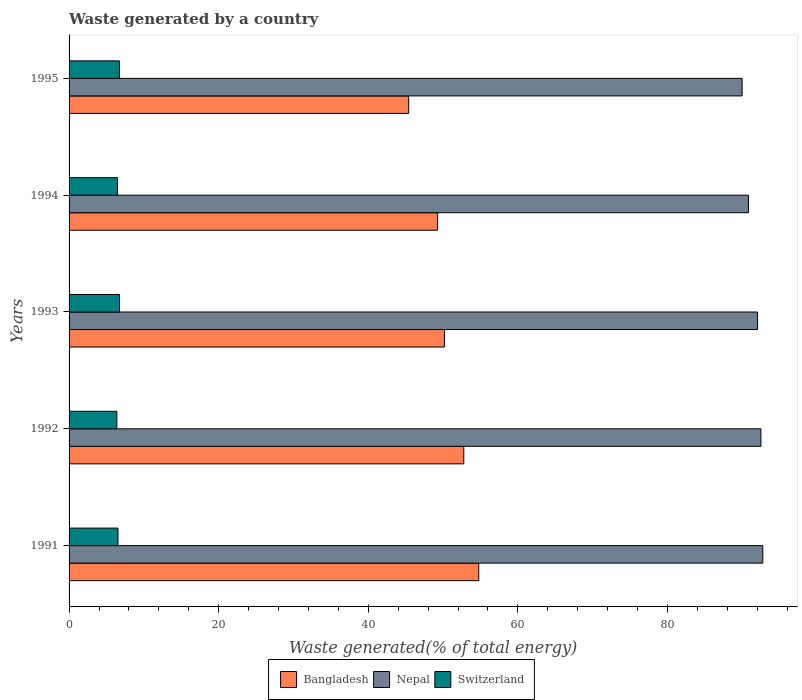Are the number of bars per tick equal to the number of legend labels?
Give a very brief answer. Yes. How many bars are there on the 3rd tick from the top?
Make the answer very short. 3. What is the label of the 2nd group of bars from the top?
Ensure brevity in your answer.  1994. What is the total waste generated in Nepal in 1995?
Offer a very short reply. 89.97. Across all years, what is the maximum total waste generated in Bangladesh?
Provide a succinct answer. 54.76. Across all years, what is the minimum total waste generated in Nepal?
Offer a terse response. 89.97. What is the total total waste generated in Bangladesh in the graph?
Make the answer very short. 252.37. What is the difference between the total waste generated in Switzerland in 1993 and that in 1994?
Offer a very short reply. 0.27. What is the difference between the total waste generated in Nepal in 1994 and the total waste generated in Switzerland in 1993?
Provide a succinct answer. 84.07. What is the average total waste generated in Switzerland per year?
Give a very brief answer. 6.58. In the year 1993, what is the difference between the total waste generated in Switzerland and total waste generated in Nepal?
Your answer should be very brief. -85.29. What is the ratio of the total waste generated in Nepal in 1993 to that in 1995?
Your answer should be very brief. 1.02. What is the difference between the highest and the second highest total waste generated in Bangladesh?
Provide a succinct answer. 2. What is the difference between the highest and the lowest total waste generated in Bangladesh?
Ensure brevity in your answer.  9.37. What does the 1st bar from the top in 1995 represents?
Provide a succinct answer. Switzerland. Are all the bars in the graph horizontal?
Give a very brief answer. Yes. How many years are there in the graph?
Give a very brief answer. 5. Are the values on the major ticks of X-axis written in scientific E-notation?
Offer a terse response. No. Does the graph contain any zero values?
Give a very brief answer. No. How are the legend labels stacked?
Offer a terse response. Horizontal. What is the title of the graph?
Offer a very short reply. Waste generated by a country. What is the label or title of the X-axis?
Your answer should be compact. Waste generated(% of total energy). What is the Waste generated(% of total energy) in Bangladesh in 1991?
Offer a very short reply. 54.76. What is the Waste generated(% of total energy) in Nepal in 1991?
Provide a succinct answer. 92.74. What is the Waste generated(% of total energy) in Switzerland in 1991?
Keep it short and to the point. 6.54. What is the Waste generated(% of total energy) in Bangladesh in 1992?
Your response must be concise. 52.77. What is the Waste generated(% of total energy) of Nepal in 1992?
Make the answer very short. 92.48. What is the Waste generated(% of total energy) in Switzerland in 1992?
Your answer should be very brief. 6.39. What is the Waste generated(% of total energy) in Bangladesh in 1993?
Provide a succinct answer. 50.18. What is the Waste generated(% of total energy) of Nepal in 1993?
Offer a very short reply. 92.04. What is the Waste generated(% of total energy) in Switzerland in 1993?
Your answer should be very brief. 6.75. What is the Waste generated(% of total energy) of Bangladesh in 1994?
Your answer should be very brief. 49.26. What is the Waste generated(% of total energy) of Nepal in 1994?
Ensure brevity in your answer.  90.82. What is the Waste generated(% of total energy) of Switzerland in 1994?
Keep it short and to the point. 6.47. What is the Waste generated(% of total energy) in Bangladesh in 1995?
Provide a short and direct response. 45.4. What is the Waste generated(% of total energy) in Nepal in 1995?
Offer a very short reply. 89.97. What is the Waste generated(% of total energy) of Switzerland in 1995?
Give a very brief answer. 6.73. Across all years, what is the maximum Waste generated(% of total energy) in Bangladesh?
Offer a very short reply. 54.76. Across all years, what is the maximum Waste generated(% of total energy) of Nepal?
Your answer should be compact. 92.74. Across all years, what is the maximum Waste generated(% of total energy) in Switzerland?
Provide a succinct answer. 6.75. Across all years, what is the minimum Waste generated(% of total energy) of Bangladesh?
Ensure brevity in your answer.  45.4. Across all years, what is the minimum Waste generated(% of total energy) in Nepal?
Offer a very short reply. 89.97. Across all years, what is the minimum Waste generated(% of total energy) of Switzerland?
Your answer should be very brief. 6.39. What is the total Waste generated(% of total energy) in Bangladesh in the graph?
Give a very brief answer. 252.37. What is the total Waste generated(% of total energy) of Nepal in the graph?
Offer a terse response. 458.05. What is the total Waste generated(% of total energy) of Switzerland in the graph?
Your answer should be compact. 32.89. What is the difference between the Waste generated(% of total energy) of Bangladesh in 1991 and that in 1992?
Ensure brevity in your answer.  2. What is the difference between the Waste generated(% of total energy) in Nepal in 1991 and that in 1992?
Ensure brevity in your answer.  0.25. What is the difference between the Waste generated(% of total energy) in Switzerland in 1991 and that in 1992?
Offer a terse response. 0.15. What is the difference between the Waste generated(% of total energy) in Bangladesh in 1991 and that in 1993?
Offer a terse response. 4.59. What is the difference between the Waste generated(% of total energy) in Nepal in 1991 and that in 1993?
Give a very brief answer. 0.7. What is the difference between the Waste generated(% of total energy) in Switzerland in 1991 and that in 1993?
Ensure brevity in your answer.  -0.21. What is the difference between the Waste generated(% of total energy) in Bangladesh in 1991 and that in 1994?
Ensure brevity in your answer.  5.5. What is the difference between the Waste generated(% of total energy) of Nepal in 1991 and that in 1994?
Keep it short and to the point. 1.92. What is the difference between the Waste generated(% of total energy) of Switzerland in 1991 and that in 1994?
Your answer should be compact. 0.07. What is the difference between the Waste generated(% of total energy) in Bangladesh in 1991 and that in 1995?
Your answer should be very brief. 9.37. What is the difference between the Waste generated(% of total energy) in Nepal in 1991 and that in 1995?
Your answer should be compact. 2.76. What is the difference between the Waste generated(% of total energy) in Switzerland in 1991 and that in 1995?
Your answer should be compact. -0.19. What is the difference between the Waste generated(% of total energy) of Bangladesh in 1992 and that in 1993?
Provide a short and direct response. 2.59. What is the difference between the Waste generated(% of total energy) of Nepal in 1992 and that in 1993?
Ensure brevity in your answer.  0.45. What is the difference between the Waste generated(% of total energy) of Switzerland in 1992 and that in 1993?
Offer a very short reply. -0.36. What is the difference between the Waste generated(% of total energy) of Bangladesh in 1992 and that in 1994?
Your answer should be very brief. 3.5. What is the difference between the Waste generated(% of total energy) of Nepal in 1992 and that in 1994?
Your response must be concise. 1.66. What is the difference between the Waste generated(% of total energy) of Switzerland in 1992 and that in 1994?
Your answer should be very brief. -0.09. What is the difference between the Waste generated(% of total energy) of Bangladesh in 1992 and that in 1995?
Provide a short and direct response. 7.37. What is the difference between the Waste generated(% of total energy) in Nepal in 1992 and that in 1995?
Your response must be concise. 2.51. What is the difference between the Waste generated(% of total energy) in Switzerland in 1992 and that in 1995?
Make the answer very short. -0.35. What is the difference between the Waste generated(% of total energy) in Bangladesh in 1993 and that in 1994?
Your answer should be compact. 0.92. What is the difference between the Waste generated(% of total energy) in Nepal in 1993 and that in 1994?
Your response must be concise. 1.22. What is the difference between the Waste generated(% of total energy) of Switzerland in 1993 and that in 1994?
Offer a very short reply. 0.27. What is the difference between the Waste generated(% of total energy) of Bangladesh in 1993 and that in 1995?
Your response must be concise. 4.78. What is the difference between the Waste generated(% of total energy) of Nepal in 1993 and that in 1995?
Give a very brief answer. 2.06. What is the difference between the Waste generated(% of total energy) of Switzerland in 1993 and that in 1995?
Give a very brief answer. 0.01. What is the difference between the Waste generated(% of total energy) of Bangladesh in 1994 and that in 1995?
Ensure brevity in your answer.  3.86. What is the difference between the Waste generated(% of total energy) in Nepal in 1994 and that in 1995?
Offer a very short reply. 0.84. What is the difference between the Waste generated(% of total energy) in Switzerland in 1994 and that in 1995?
Offer a terse response. -0.26. What is the difference between the Waste generated(% of total energy) in Bangladesh in 1991 and the Waste generated(% of total energy) in Nepal in 1992?
Make the answer very short. -37.72. What is the difference between the Waste generated(% of total energy) of Bangladesh in 1991 and the Waste generated(% of total energy) of Switzerland in 1992?
Ensure brevity in your answer.  48.38. What is the difference between the Waste generated(% of total energy) in Nepal in 1991 and the Waste generated(% of total energy) in Switzerland in 1992?
Keep it short and to the point. 86.35. What is the difference between the Waste generated(% of total energy) of Bangladesh in 1991 and the Waste generated(% of total energy) of Nepal in 1993?
Give a very brief answer. -37.27. What is the difference between the Waste generated(% of total energy) in Bangladesh in 1991 and the Waste generated(% of total energy) in Switzerland in 1993?
Make the answer very short. 48.02. What is the difference between the Waste generated(% of total energy) of Nepal in 1991 and the Waste generated(% of total energy) of Switzerland in 1993?
Provide a short and direct response. 85.99. What is the difference between the Waste generated(% of total energy) of Bangladesh in 1991 and the Waste generated(% of total energy) of Nepal in 1994?
Make the answer very short. -36.05. What is the difference between the Waste generated(% of total energy) in Bangladesh in 1991 and the Waste generated(% of total energy) in Switzerland in 1994?
Offer a terse response. 48.29. What is the difference between the Waste generated(% of total energy) in Nepal in 1991 and the Waste generated(% of total energy) in Switzerland in 1994?
Provide a succinct answer. 86.26. What is the difference between the Waste generated(% of total energy) in Bangladesh in 1991 and the Waste generated(% of total energy) in Nepal in 1995?
Your response must be concise. -35.21. What is the difference between the Waste generated(% of total energy) of Bangladesh in 1991 and the Waste generated(% of total energy) of Switzerland in 1995?
Ensure brevity in your answer.  48.03. What is the difference between the Waste generated(% of total energy) of Nepal in 1991 and the Waste generated(% of total energy) of Switzerland in 1995?
Give a very brief answer. 86. What is the difference between the Waste generated(% of total energy) of Bangladesh in 1992 and the Waste generated(% of total energy) of Nepal in 1993?
Your response must be concise. -39.27. What is the difference between the Waste generated(% of total energy) of Bangladesh in 1992 and the Waste generated(% of total energy) of Switzerland in 1993?
Your response must be concise. 46.02. What is the difference between the Waste generated(% of total energy) in Nepal in 1992 and the Waste generated(% of total energy) in Switzerland in 1993?
Offer a terse response. 85.74. What is the difference between the Waste generated(% of total energy) of Bangladesh in 1992 and the Waste generated(% of total energy) of Nepal in 1994?
Offer a very short reply. -38.05. What is the difference between the Waste generated(% of total energy) of Bangladesh in 1992 and the Waste generated(% of total energy) of Switzerland in 1994?
Give a very brief answer. 46.29. What is the difference between the Waste generated(% of total energy) in Nepal in 1992 and the Waste generated(% of total energy) in Switzerland in 1994?
Ensure brevity in your answer.  86.01. What is the difference between the Waste generated(% of total energy) in Bangladesh in 1992 and the Waste generated(% of total energy) in Nepal in 1995?
Your answer should be compact. -37.21. What is the difference between the Waste generated(% of total energy) in Bangladesh in 1992 and the Waste generated(% of total energy) in Switzerland in 1995?
Give a very brief answer. 46.03. What is the difference between the Waste generated(% of total energy) of Nepal in 1992 and the Waste generated(% of total energy) of Switzerland in 1995?
Your answer should be very brief. 85.75. What is the difference between the Waste generated(% of total energy) in Bangladesh in 1993 and the Waste generated(% of total energy) in Nepal in 1994?
Make the answer very short. -40.64. What is the difference between the Waste generated(% of total energy) in Bangladesh in 1993 and the Waste generated(% of total energy) in Switzerland in 1994?
Offer a very short reply. 43.71. What is the difference between the Waste generated(% of total energy) of Nepal in 1993 and the Waste generated(% of total energy) of Switzerland in 1994?
Give a very brief answer. 85.56. What is the difference between the Waste generated(% of total energy) in Bangladesh in 1993 and the Waste generated(% of total energy) in Nepal in 1995?
Offer a very short reply. -39.79. What is the difference between the Waste generated(% of total energy) in Bangladesh in 1993 and the Waste generated(% of total energy) in Switzerland in 1995?
Your response must be concise. 43.44. What is the difference between the Waste generated(% of total energy) in Nepal in 1993 and the Waste generated(% of total energy) in Switzerland in 1995?
Keep it short and to the point. 85.3. What is the difference between the Waste generated(% of total energy) in Bangladesh in 1994 and the Waste generated(% of total energy) in Nepal in 1995?
Make the answer very short. -40.71. What is the difference between the Waste generated(% of total energy) in Bangladesh in 1994 and the Waste generated(% of total energy) in Switzerland in 1995?
Make the answer very short. 42.53. What is the difference between the Waste generated(% of total energy) of Nepal in 1994 and the Waste generated(% of total energy) of Switzerland in 1995?
Keep it short and to the point. 84.08. What is the average Waste generated(% of total energy) in Bangladesh per year?
Keep it short and to the point. 50.47. What is the average Waste generated(% of total energy) in Nepal per year?
Provide a short and direct response. 91.61. What is the average Waste generated(% of total energy) of Switzerland per year?
Offer a very short reply. 6.58. In the year 1991, what is the difference between the Waste generated(% of total energy) of Bangladesh and Waste generated(% of total energy) of Nepal?
Provide a short and direct response. -37.97. In the year 1991, what is the difference between the Waste generated(% of total energy) of Bangladesh and Waste generated(% of total energy) of Switzerland?
Make the answer very short. 48.22. In the year 1991, what is the difference between the Waste generated(% of total energy) in Nepal and Waste generated(% of total energy) in Switzerland?
Make the answer very short. 86.2. In the year 1992, what is the difference between the Waste generated(% of total energy) of Bangladesh and Waste generated(% of total energy) of Nepal?
Your answer should be very brief. -39.72. In the year 1992, what is the difference between the Waste generated(% of total energy) in Bangladesh and Waste generated(% of total energy) in Switzerland?
Keep it short and to the point. 46.38. In the year 1992, what is the difference between the Waste generated(% of total energy) in Nepal and Waste generated(% of total energy) in Switzerland?
Your answer should be very brief. 86.1. In the year 1993, what is the difference between the Waste generated(% of total energy) of Bangladesh and Waste generated(% of total energy) of Nepal?
Offer a terse response. -41.86. In the year 1993, what is the difference between the Waste generated(% of total energy) in Bangladesh and Waste generated(% of total energy) in Switzerland?
Provide a short and direct response. 43.43. In the year 1993, what is the difference between the Waste generated(% of total energy) in Nepal and Waste generated(% of total energy) in Switzerland?
Your answer should be very brief. 85.29. In the year 1994, what is the difference between the Waste generated(% of total energy) in Bangladesh and Waste generated(% of total energy) in Nepal?
Provide a short and direct response. -41.56. In the year 1994, what is the difference between the Waste generated(% of total energy) of Bangladesh and Waste generated(% of total energy) of Switzerland?
Provide a succinct answer. 42.79. In the year 1994, what is the difference between the Waste generated(% of total energy) in Nepal and Waste generated(% of total energy) in Switzerland?
Give a very brief answer. 84.35. In the year 1995, what is the difference between the Waste generated(% of total energy) in Bangladesh and Waste generated(% of total energy) in Nepal?
Provide a succinct answer. -44.58. In the year 1995, what is the difference between the Waste generated(% of total energy) in Bangladesh and Waste generated(% of total energy) in Switzerland?
Your answer should be compact. 38.66. In the year 1995, what is the difference between the Waste generated(% of total energy) in Nepal and Waste generated(% of total energy) in Switzerland?
Offer a very short reply. 83.24. What is the ratio of the Waste generated(% of total energy) of Bangladesh in 1991 to that in 1992?
Make the answer very short. 1.04. What is the ratio of the Waste generated(% of total energy) in Switzerland in 1991 to that in 1992?
Provide a succinct answer. 1.02. What is the ratio of the Waste generated(% of total energy) in Bangladesh in 1991 to that in 1993?
Give a very brief answer. 1.09. What is the ratio of the Waste generated(% of total energy) in Nepal in 1991 to that in 1993?
Make the answer very short. 1.01. What is the ratio of the Waste generated(% of total energy) of Switzerland in 1991 to that in 1993?
Your answer should be very brief. 0.97. What is the ratio of the Waste generated(% of total energy) of Bangladesh in 1991 to that in 1994?
Your answer should be very brief. 1.11. What is the ratio of the Waste generated(% of total energy) of Nepal in 1991 to that in 1994?
Your answer should be very brief. 1.02. What is the ratio of the Waste generated(% of total energy) in Switzerland in 1991 to that in 1994?
Your answer should be very brief. 1.01. What is the ratio of the Waste generated(% of total energy) of Bangladesh in 1991 to that in 1995?
Provide a succinct answer. 1.21. What is the ratio of the Waste generated(% of total energy) in Nepal in 1991 to that in 1995?
Your response must be concise. 1.03. What is the ratio of the Waste generated(% of total energy) of Switzerland in 1991 to that in 1995?
Ensure brevity in your answer.  0.97. What is the ratio of the Waste generated(% of total energy) of Bangladesh in 1992 to that in 1993?
Offer a terse response. 1.05. What is the ratio of the Waste generated(% of total energy) in Switzerland in 1992 to that in 1993?
Give a very brief answer. 0.95. What is the ratio of the Waste generated(% of total energy) in Bangladesh in 1992 to that in 1994?
Provide a short and direct response. 1.07. What is the ratio of the Waste generated(% of total energy) in Nepal in 1992 to that in 1994?
Make the answer very short. 1.02. What is the ratio of the Waste generated(% of total energy) in Switzerland in 1992 to that in 1994?
Keep it short and to the point. 0.99. What is the ratio of the Waste generated(% of total energy) of Bangladesh in 1992 to that in 1995?
Your answer should be compact. 1.16. What is the ratio of the Waste generated(% of total energy) in Nepal in 1992 to that in 1995?
Give a very brief answer. 1.03. What is the ratio of the Waste generated(% of total energy) in Switzerland in 1992 to that in 1995?
Ensure brevity in your answer.  0.95. What is the ratio of the Waste generated(% of total energy) of Bangladesh in 1993 to that in 1994?
Provide a succinct answer. 1.02. What is the ratio of the Waste generated(% of total energy) of Nepal in 1993 to that in 1994?
Your answer should be very brief. 1.01. What is the ratio of the Waste generated(% of total energy) in Switzerland in 1993 to that in 1994?
Provide a short and direct response. 1.04. What is the ratio of the Waste generated(% of total energy) in Bangladesh in 1993 to that in 1995?
Provide a succinct answer. 1.11. What is the ratio of the Waste generated(% of total energy) in Nepal in 1993 to that in 1995?
Make the answer very short. 1.02. What is the ratio of the Waste generated(% of total energy) of Switzerland in 1993 to that in 1995?
Make the answer very short. 1. What is the ratio of the Waste generated(% of total energy) in Bangladesh in 1994 to that in 1995?
Your response must be concise. 1.09. What is the ratio of the Waste generated(% of total energy) of Nepal in 1994 to that in 1995?
Give a very brief answer. 1.01. What is the ratio of the Waste generated(% of total energy) of Switzerland in 1994 to that in 1995?
Offer a terse response. 0.96. What is the difference between the highest and the second highest Waste generated(% of total energy) in Bangladesh?
Your answer should be very brief. 2. What is the difference between the highest and the second highest Waste generated(% of total energy) of Nepal?
Provide a succinct answer. 0.25. What is the difference between the highest and the second highest Waste generated(% of total energy) of Switzerland?
Offer a very short reply. 0.01. What is the difference between the highest and the lowest Waste generated(% of total energy) of Bangladesh?
Ensure brevity in your answer.  9.37. What is the difference between the highest and the lowest Waste generated(% of total energy) of Nepal?
Your answer should be very brief. 2.76. What is the difference between the highest and the lowest Waste generated(% of total energy) of Switzerland?
Provide a short and direct response. 0.36. 